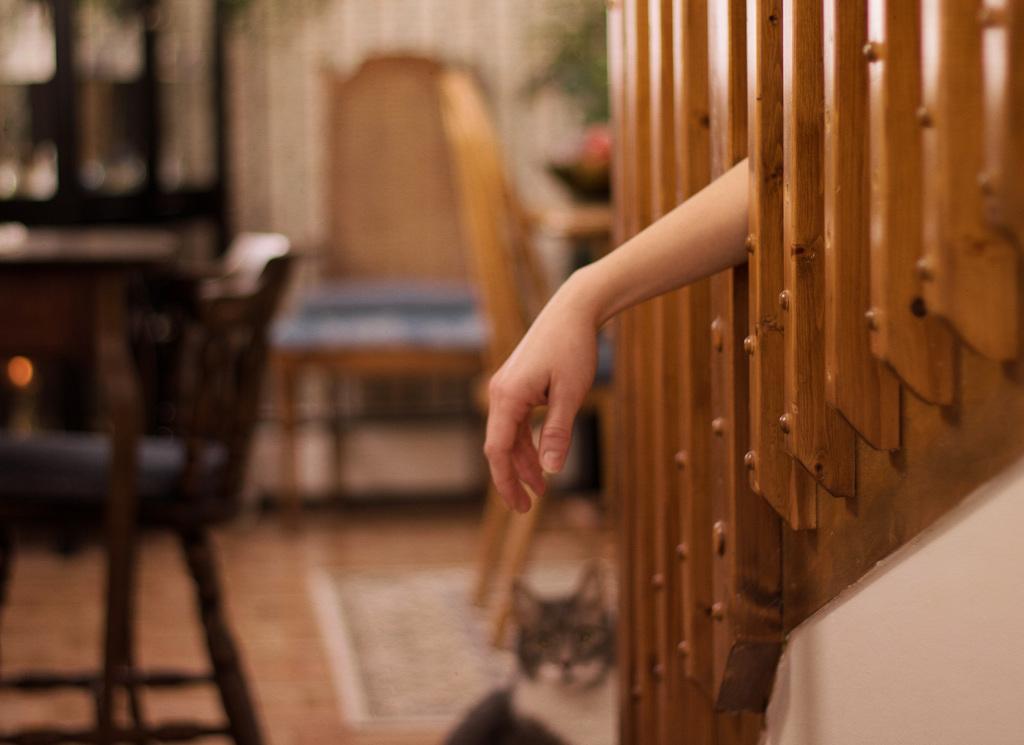How would you summarize this image in a sentence or two? There is a room. We can see in background table,chairs and wooden stick. In the center we have a human hand. 